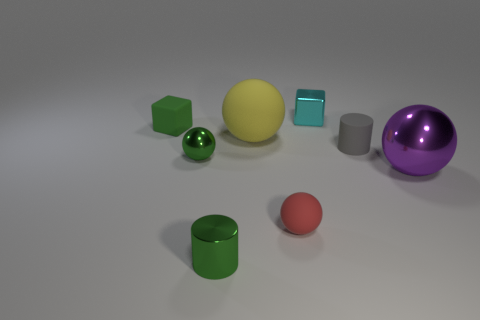There is a small matte object that is on the left side of the green shiny cylinder; what is its shape?
Offer a terse response. Cube. There is another cylinder that is the same size as the green cylinder; what color is it?
Give a very brief answer. Gray. Does the block to the right of the green rubber block have the same material as the tiny green ball?
Make the answer very short. Yes. There is a metal object that is both in front of the small green ball and to the left of the gray matte object; how big is it?
Offer a very short reply. Small. There is a metallic ball on the right side of the tiny green metal cylinder; what size is it?
Your response must be concise. Large. There is a matte object that is the same color as the small metallic sphere; what shape is it?
Provide a succinct answer. Cube. There is a rubber object that is behind the big object that is behind the large thing right of the small red rubber sphere; what shape is it?
Keep it short and to the point. Cube. How many other things are there of the same shape as the yellow matte thing?
Give a very brief answer. 3. How many shiny objects are tiny balls or small green cylinders?
Keep it short and to the point. 2. What material is the sphere in front of the purple shiny object behind the shiny cylinder?
Ensure brevity in your answer.  Rubber. 